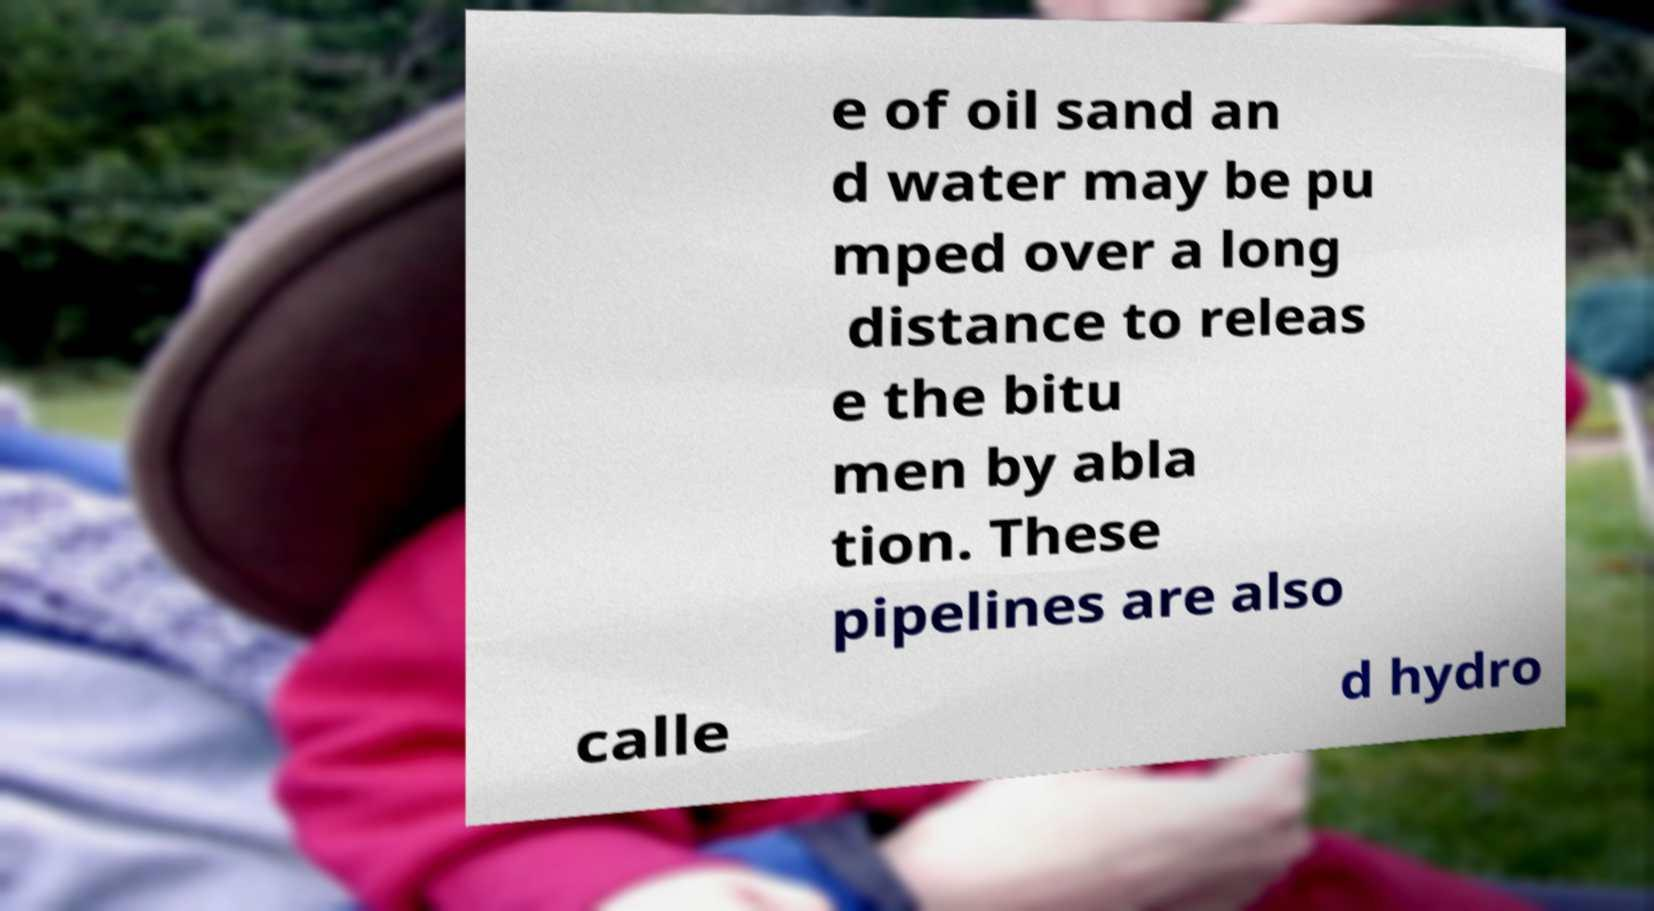Can you read and provide the text displayed in the image?This photo seems to have some interesting text. Can you extract and type it out for me? e of oil sand an d water may be pu mped over a long distance to releas e the bitu men by abla tion. These pipelines are also calle d hydro 